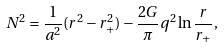Convert formula to latex. <formula><loc_0><loc_0><loc_500><loc_500>N ^ { 2 } = { \frac { 1 } { a ^ { 2 } } } ( r ^ { 2 } - r _ { + } ^ { 2 } ) - { \frac { 2 G } { \pi } } q ^ { 2 } \ln { \frac { r } { r _ { + } } } ,</formula> 